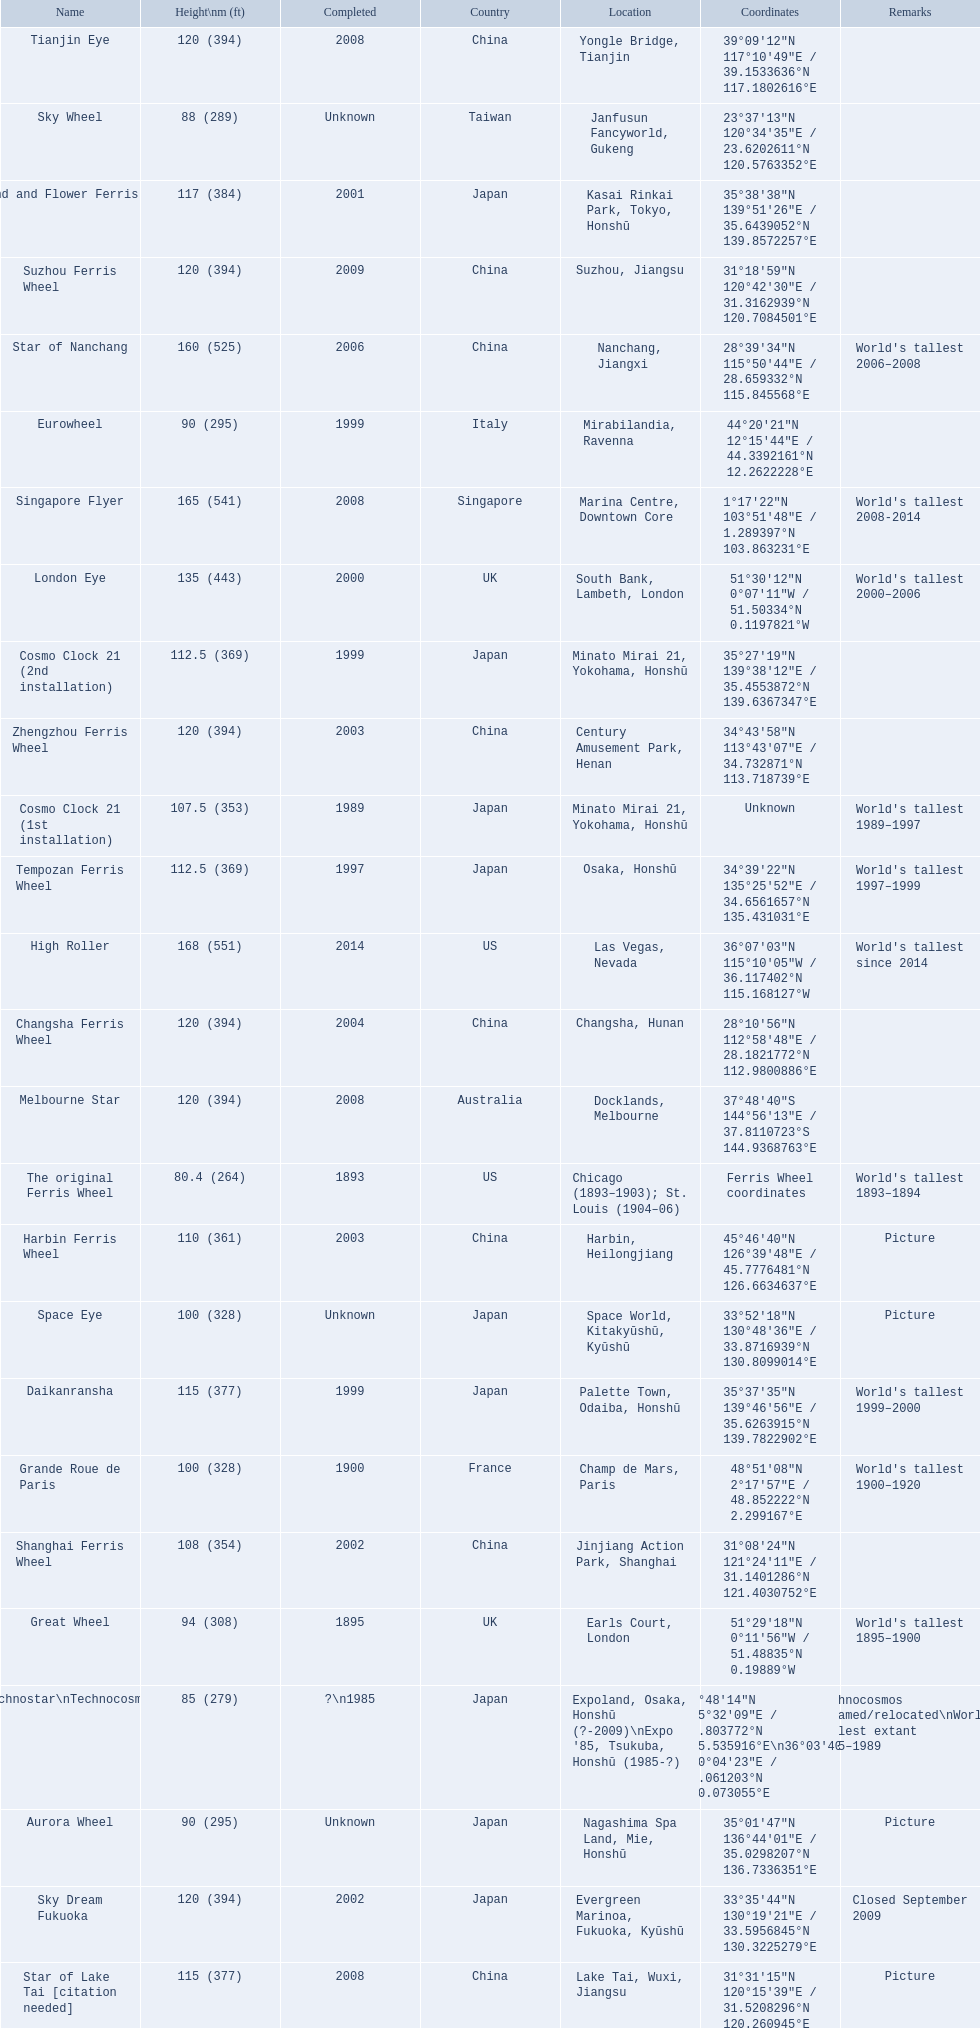What are the different completion dates for the ferris wheel list? 2014, 2008, 2006, 2000, 2009, 2008, 2008, 2004, 2003, 2002, 2001, 2008, 1999, 1999, 1997, 2003, 2002, 1989, Unknown, 1900, 1895, Unknown, 1999, Unknown, ?\n1985, 1893. Which dates for the star of lake tai, star of nanchang, melbourne star? 2006, 2008, 2008. Which is the oldest? 2006. What ride name is this for? Star of Nanchang. 